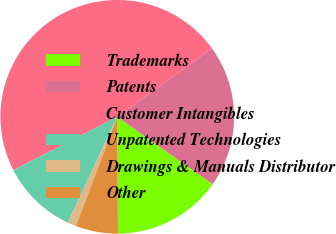Convert chart to OTSL. <chart><loc_0><loc_0><loc_500><loc_500><pie_chart><fcel>Trademarks<fcel>Patents<fcel>Customer Intangibles<fcel>Unpatented Technologies<fcel>Drawings & Manuals Distributor<fcel>Other<nl><fcel>15.12%<fcel>19.76%<fcel>47.58%<fcel>10.48%<fcel>1.21%<fcel>5.85%<nl></chart> 